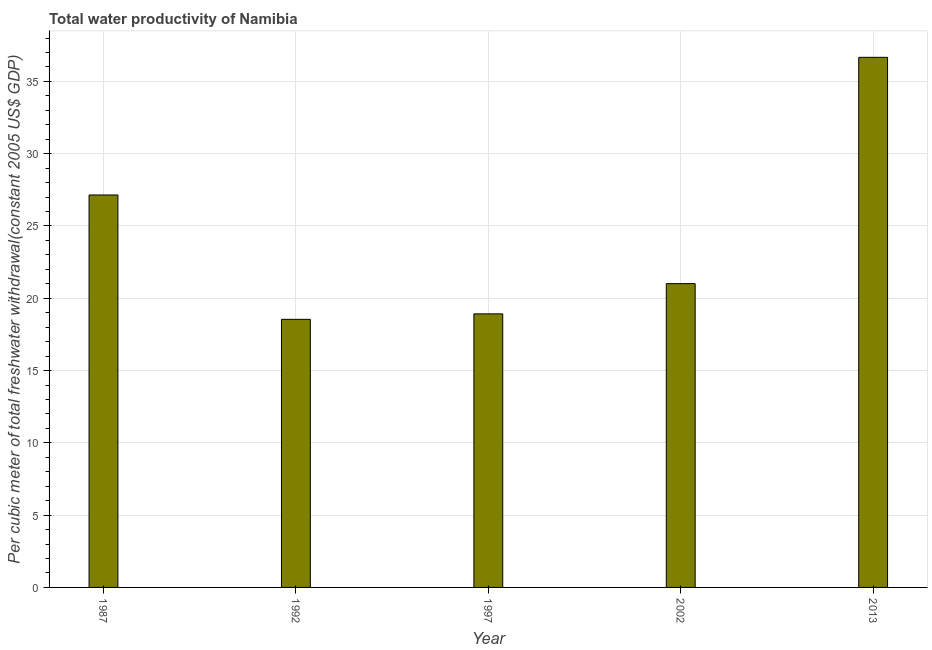Does the graph contain grids?
Make the answer very short. Yes. What is the title of the graph?
Offer a very short reply. Total water productivity of Namibia. What is the label or title of the X-axis?
Offer a very short reply. Year. What is the label or title of the Y-axis?
Your answer should be very brief. Per cubic meter of total freshwater withdrawal(constant 2005 US$ GDP). What is the total water productivity in 2002?
Keep it short and to the point. 21.01. Across all years, what is the maximum total water productivity?
Keep it short and to the point. 36.67. Across all years, what is the minimum total water productivity?
Provide a short and direct response. 18.54. What is the sum of the total water productivity?
Your answer should be compact. 122.29. What is the difference between the total water productivity in 1997 and 2002?
Give a very brief answer. -2.09. What is the average total water productivity per year?
Provide a succinct answer. 24.46. What is the median total water productivity?
Keep it short and to the point. 21.01. Is the total water productivity in 1997 less than that in 2002?
Provide a succinct answer. Yes. Is the difference between the total water productivity in 1992 and 2013 greater than the difference between any two years?
Provide a short and direct response. Yes. What is the difference between the highest and the second highest total water productivity?
Your response must be concise. 9.52. What is the difference between the highest and the lowest total water productivity?
Your response must be concise. 18.12. How many bars are there?
Offer a terse response. 5. How many years are there in the graph?
Give a very brief answer. 5. What is the Per cubic meter of total freshwater withdrawal(constant 2005 US$ GDP) in 1987?
Offer a very short reply. 27.14. What is the Per cubic meter of total freshwater withdrawal(constant 2005 US$ GDP) of 1992?
Keep it short and to the point. 18.54. What is the Per cubic meter of total freshwater withdrawal(constant 2005 US$ GDP) of 1997?
Offer a terse response. 18.92. What is the Per cubic meter of total freshwater withdrawal(constant 2005 US$ GDP) of 2002?
Your answer should be very brief. 21.01. What is the Per cubic meter of total freshwater withdrawal(constant 2005 US$ GDP) in 2013?
Make the answer very short. 36.67. What is the difference between the Per cubic meter of total freshwater withdrawal(constant 2005 US$ GDP) in 1987 and 1992?
Make the answer very short. 8.6. What is the difference between the Per cubic meter of total freshwater withdrawal(constant 2005 US$ GDP) in 1987 and 1997?
Ensure brevity in your answer.  8.22. What is the difference between the Per cubic meter of total freshwater withdrawal(constant 2005 US$ GDP) in 1987 and 2002?
Provide a succinct answer. 6.13. What is the difference between the Per cubic meter of total freshwater withdrawal(constant 2005 US$ GDP) in 1987 and 2013?
Keep it short and to the point. -9.52. What is the difference between the Per cubic meter of total freshwater withdrawal(constant 2005 US$ GDP) in 1992 and 1997?
Provide a succinct answer. -0.38. What is the difference between the Per cubic meter of total freshwater withdrawal(constant 2005 US$ GDP) in 1992 and 2002?
Ensure brevity in your answer.  -2.47. What is the difference between the Per cubic meter of total freshwater withdrawal(constant 2005 US$ GDP) in 1992 and 2013?
Ensure brevity in your answer.  -18.12. What is the difference between the Per cubic meter of total freshwater withdrawal(constant 2005 US$ GDP) in 1997 and 2002?
Your answer should be very brief. -2.09. What is the difference between the Per cubic meter of total freshwater withdrawal(constant 2005 US$ GDP) in 1997 and 2013?
Keep it short and to the point. -17.74. What is the difference between the Per cubic meter of total freshwater withdrawal(constant 2005 US$ GDP) in 2002 and 2013?
Offer a very short reply. -15.65. What is the ratio of the Per cubic meter of total freshwater withdrawal(constant 2005 US$ GDP) in 1987 to that in 1992?
Provide a succinct answer. 1.46. What is the ratio of the Per cubic meter of total freshwater withdrawal(constant 2005 US$ GDP) in 1987 to that in 1997?
Offer a very short reply. 1.44. What is the ratio of the Per cubic meter of total freshwater withdrawal(constant 2005 US$ GDP) in 1987 to that in 2002?
Your answer should be compact. 1.29. What is the ratio of the Per cubic meter of total freshwater withdrawal(constant 2005 US$ GDP) in 1987 to that in 2013?
Your answer should be compact. 0.74. What is the ratio of the Per cubic meter of total freshwater withdrawal(constant 2005 US$ GDP) in 1992 to that in 2002?
Provide a short and direct response. 0.88. What is the ratio of the Per cubic meter of total freshwater withdrawal(constant 2005 US$ GDP) in 1992 to that in 2013?
Your response must be concise. 0.51. What is the ratio of the Per cubic meter of total freshwater withdrawal(constant 2005 US$ GDP) in 1997 to that in 2013?
Keep it short and to the point. 0.52. What is the ratio of the Per cubic meter of total freshwater withdrawal(constant 2005 US$ GDP) in 2002 to that in 2013?
Offer a terse response. 0.57. 